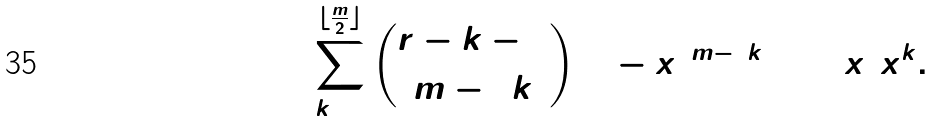Convert formula to latex. <formula><loc_0><loc_0><loc_500><loc_500>\sum _ { k = 0 } ^ { \lfloor \frac { m } { 2 } \rfloor } \binom { r - k - 1 } { m - 2 k } ( 1 - x ) ^ { m - 2 k } ( 1 + x ) x ^ { k } .</formula> 